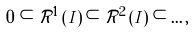<formula> <loc_0><loc_0><loc_500><loc_500>0 \subset { \mathcal { R } } ^ { 1 } \left ( I \right ) \subset { \mathcal { R } } ^ { 2 } \left ( I \right ) \subset \dots ,</formula> 